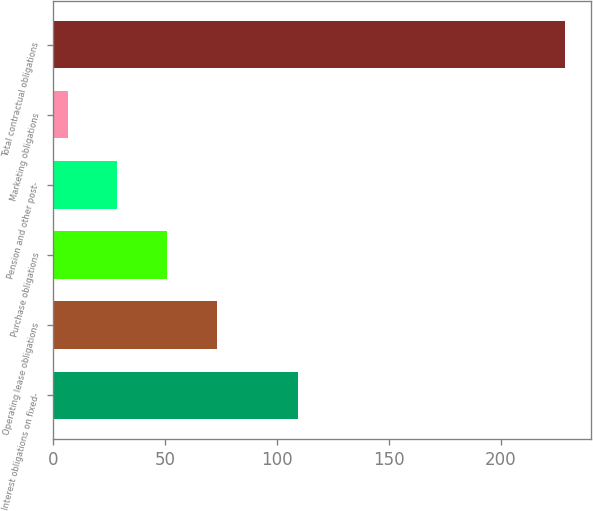<chart> <loc_0><loc_0><loc_500><loc_500><bar_chart><fcel>Interest obligations on fixed-<fcel>Operating lease obligations<fcel>Purchase obligations<fcel>Pension and other post-<fcel>Marketing obligations<fcel>Total contractual obligations<nl><fcel>109.6<fcel>73.23<fcel>51.02<fcel>28.81<fcel>6.6<fcel>228.7<nl></chart> 